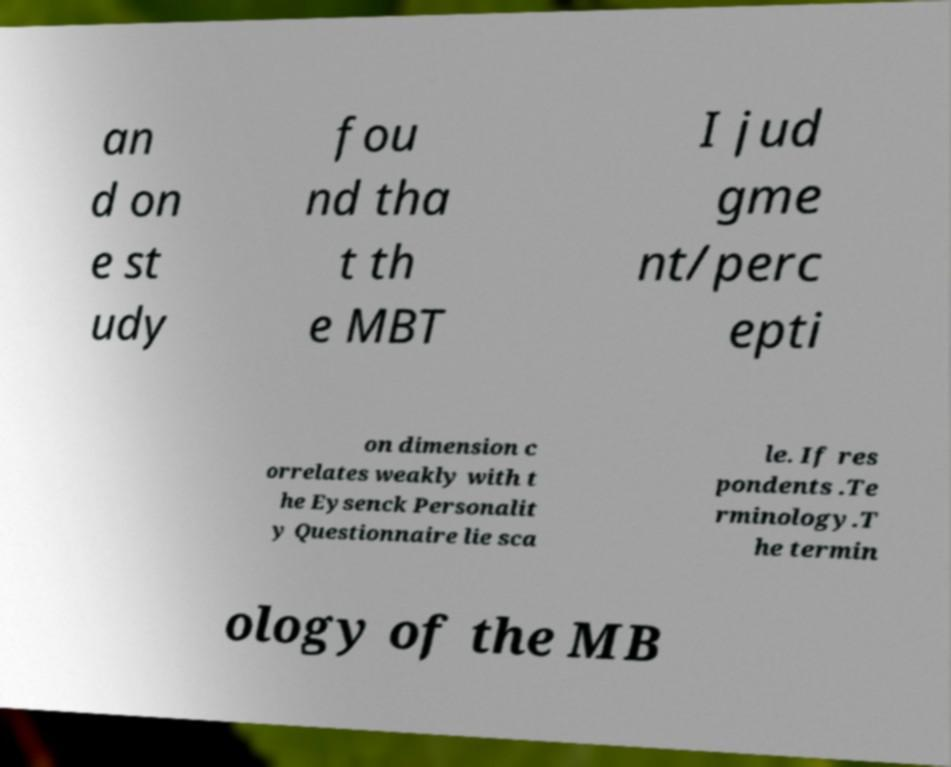Can you read and provide the text displayed in the image?This photo seems to have some interesting text. Can you extract and type it out for me? an d on e st udy fou nd tha t th e MBT I jud gme nt/perc epti on dimension c orrelates weakly with t he Eysenck Personalit y Questionnaire lie sca le. If res pondents .Te rminology.T he termin ology of the MB 